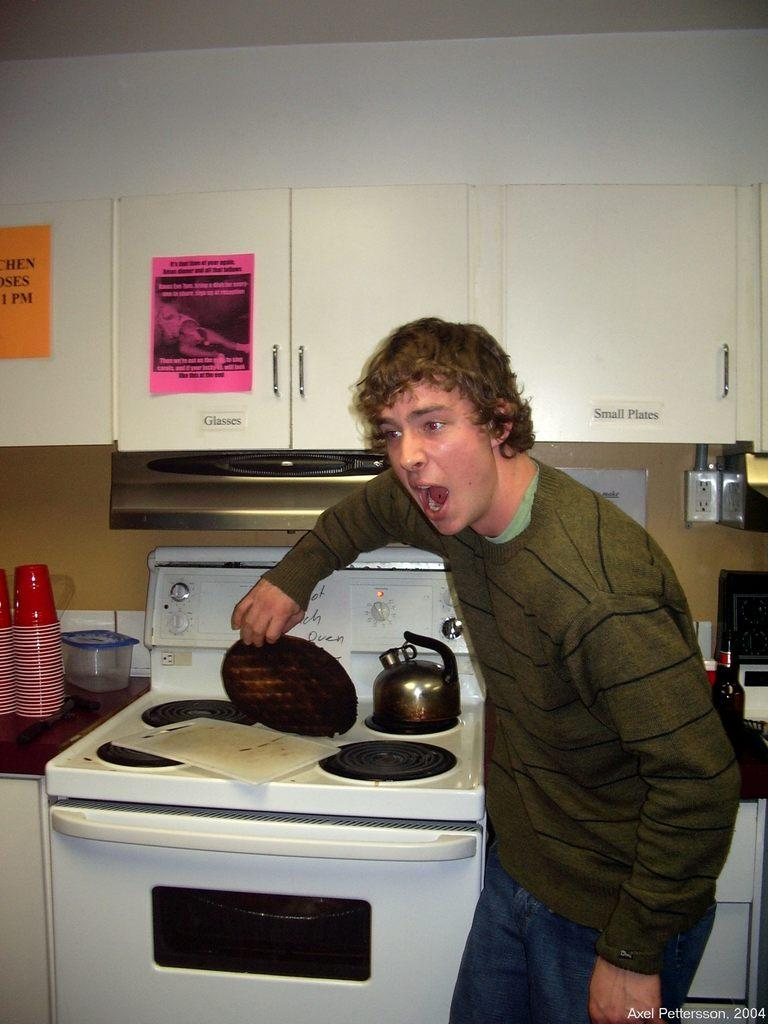<image>
Offer a succinct explanation of the picture presented. a man standing in front of a stove with a label on the cabinet above it that says 'glasses' 